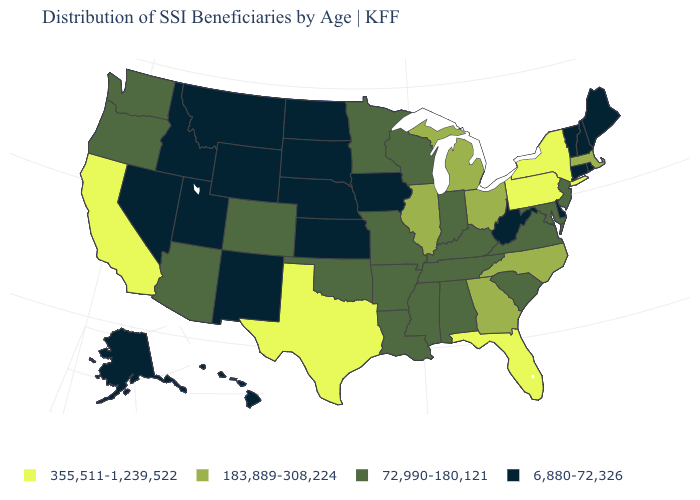What is the highest value in the USA?
Keep it brief. 355,511-1,239,522. What is the value of New Hampshire?
Give a very brief answer. 6,880-72,326. Name the states that have a value in the range 183,889-308,224?
Write a very short answer. Georgia, Illinois, Massachusetts, Michigan, North Carolina, Ohio. What is the value of Massachusetts?
Keep it brief. 183,889-308,224. Which states have the lowest value in the USA?
Short answer required. Alaska, Connecticut, Delaware, Hawaii, Idaho, Iowa, Kansas, Maine, Montana, Nebraska, Nevada, New Hampshire, New Mexico, North Dakota, Rhode Island, South Dakota, Utah, Vermont, West Virginia, Wyoming. Does Montana have the lowest value in the USA?
Concise answer only. Yes. What is the value of Rhode Island?
Keep it brief. 6,880-72,326. Among the states that border New Jersey , does Delaware have the highest value?
Give a very brief answer. No. Which states have the lowest value in the Northeast?
Be succinct. Connecticut, Maine, New Hampshire, Rhode Island, Vermont. Does Iowa have a lower value than Tennessee?
Keep it brief. Yes. What is the lowest value in the MidWest?
Short answer required. 6,880-72,326. Does South Dakota have the same value as Kentucky?
Be succinct. No. Which states have the highest value in the USA?
Quick response, please. California, Florida, New York, Pennsylvania, Texas. Does Alabama have the highest value in the South?
Short answer required. No. How many symbols are there in the legend?
Write a very short answer. 4. 